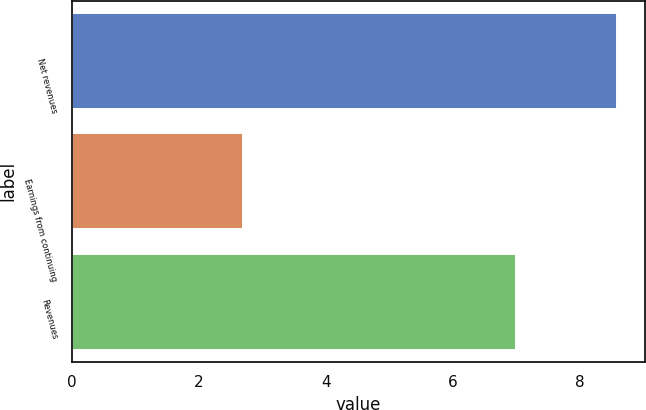Convert chart. <chart><loc_0><loc_0><loc_500><loc_500><bar_chart><fcel>Net revenues<fcel>Earnings from continuing<fcel>Revenues<nl><fcel>8.6<fcel>2.7<fcel>7<nl></chart> 